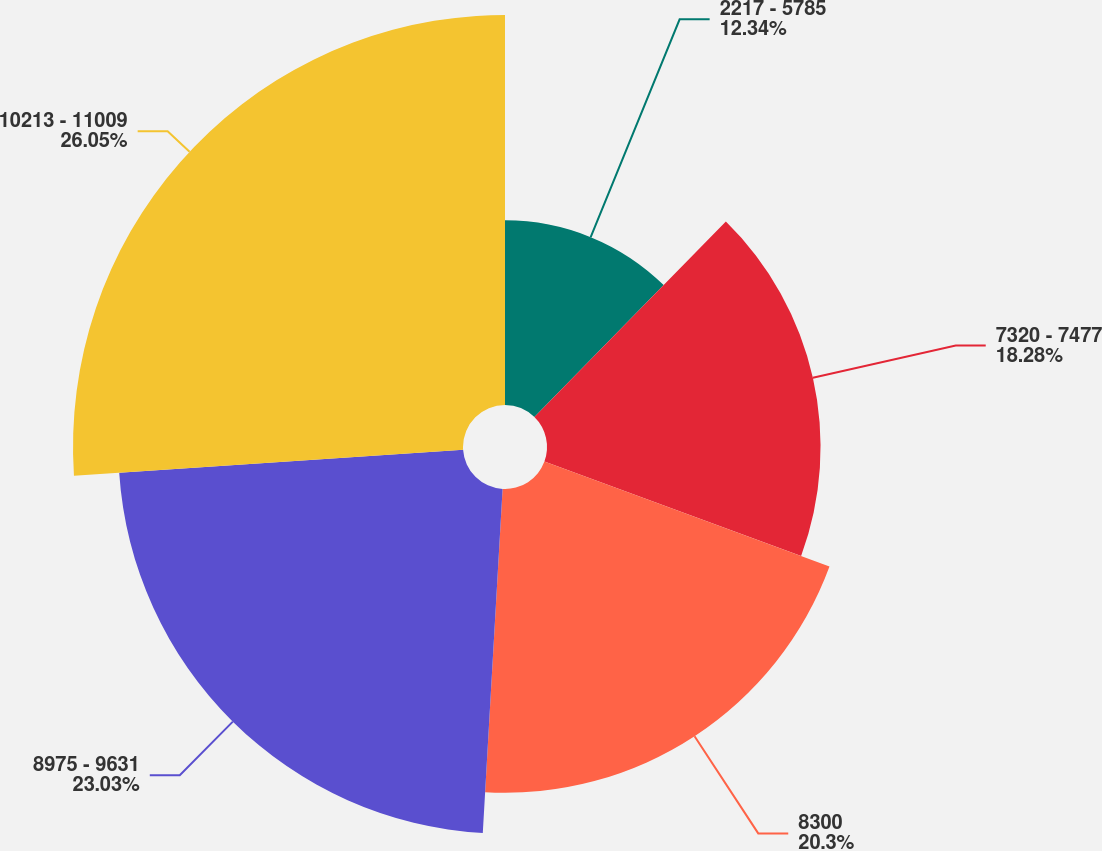Convert chart. <chart><loc_0><loc_0><loc_500><loc_500><pie_chart><fcel>2217 - 5785<fcel>7320 - 7477<fcel>8300<fcel>8975 - 9631<fcel>10213 - 11009<nl><fcel>12.34%<fcel>18.28%<fcel>20.3%<fcel>23.03%<fcel>26.06%<nl></chart> 